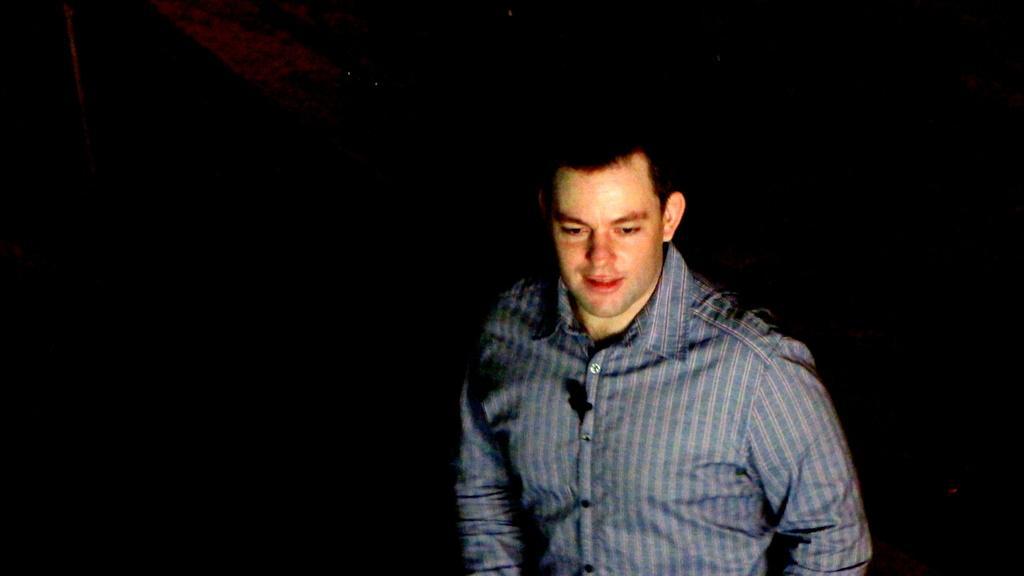How would you summarize this image in a sentence or two? In this picture we can see a man smiling and in the background it is dark. 